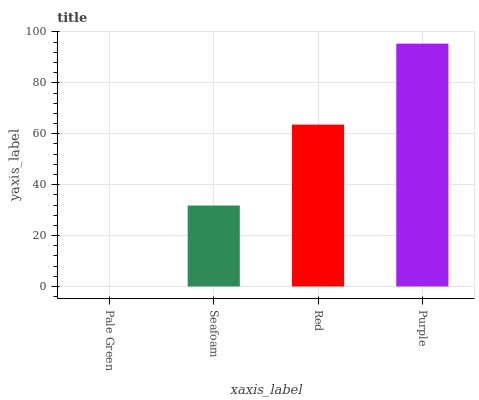Is Pale Green the minimum?
Answer yes or no. Yes. Is Purple the maximum?
Answer yes or no. Yes. Is Seafoam the minimum?
Answer yes or no. No. Is Seafoam the maximum?
Answer yes or no. No. Is Seafoam greater than Pale Green?
Answer yes or no. Yes. Is Pale Green less than Seafoam?
Answer yes or no. Yes. Is Pale Green greater than Seafoam?
Answer yes or no. No. Is Seafoam less than Pale Green?
Answer yes or no. No. Is Red the high median?
Answer yes or no. Yes. Is Seafoam the low median?
Answer yes or no. Yes. Is Pale Green the high median?
Answer yes or no. No. Is Pale Green the low median?
Answer yes or no. No. 